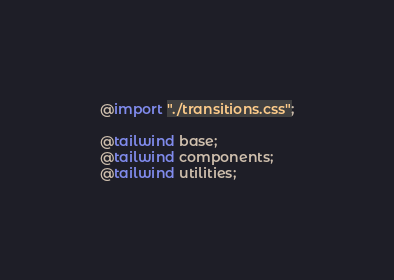<code> <loc_0><loc_0><loc_500><loc_500><_CSS_>@import "./transitions.css";

@tailwind base;
@tailwind components;
@tailwind utilities;
</code> 